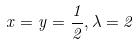<formula> <loc_0><loc_0><loc_500><loc_500>x = y = \frac { 1 } { 2 } , \lambda = 2</formula> 